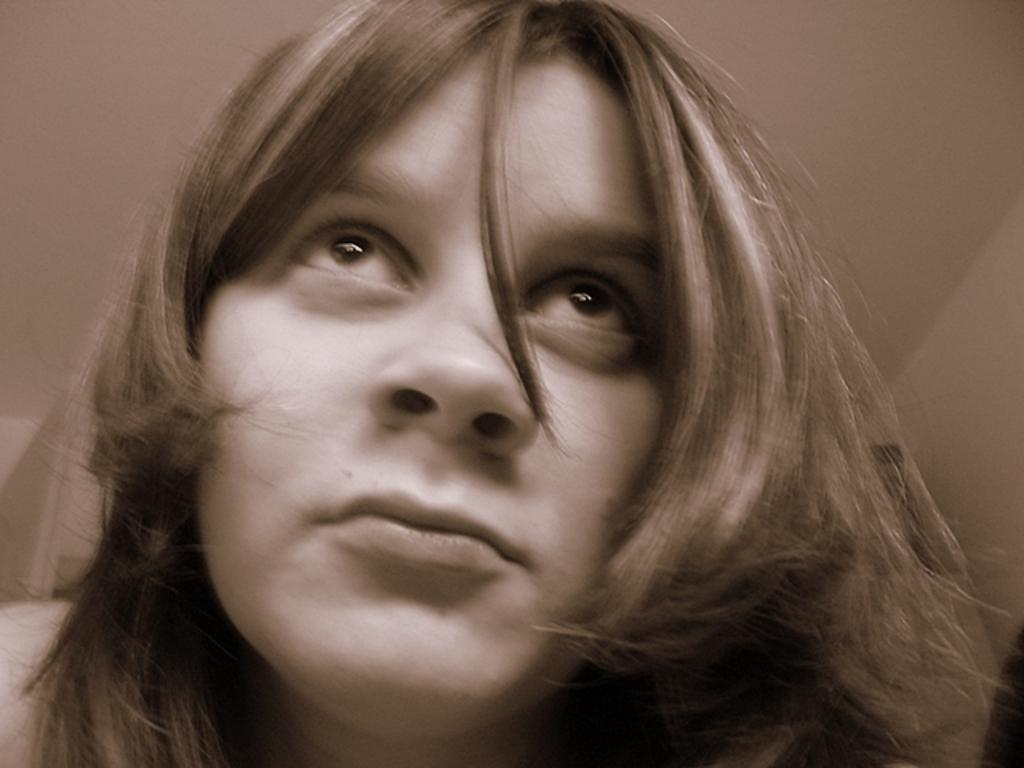Who is the main subject in the image? There is a girl in the image. What type of box is the girl holding in the image? There is no box present in the image; the girl is the only subject mentioned. 